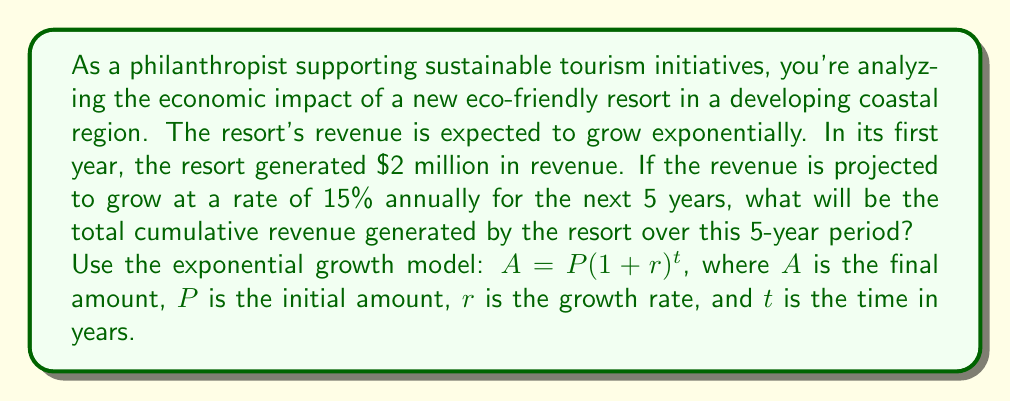Teach me how to tackle this problem. Let's approach this step-by-step:

1) We'll use the exponential growth model for each year:
   $A = P(1 + r)^t$, where $r = 0.15$ (15% growth rate)

2) Calculate revenue for each year:
   Year 1: $2,000,000 (given)
   Year 2: $2,000,000 * (1 + 0.15)^1 = 2,300,000
   Year 3: $2,000,000 * (1 + 0.15)^2 = 2,645,000
   Year 4: $2,000,000 * (1 + 0.15)^3 = 3,041,750
   Year 5: $2,000,000 * (1 + 0.15)^4 = 3,498,012.50

3) To find the total cumulative revenue, we need to sum these values:

   $$\sum_{t=0}^4 2,000,000 * (1.15)^t$$

4) This can be calculated as:
   $2,000,000 + 2,300,000 + 2,645,000 + 3,041,750 + 3,498,012.50$

5) The sum equals $13,484,762.50

Therefore, the total cumulative revenue over the 5-year period is $13,484,762.50.
Answer: $13,484,762.50 